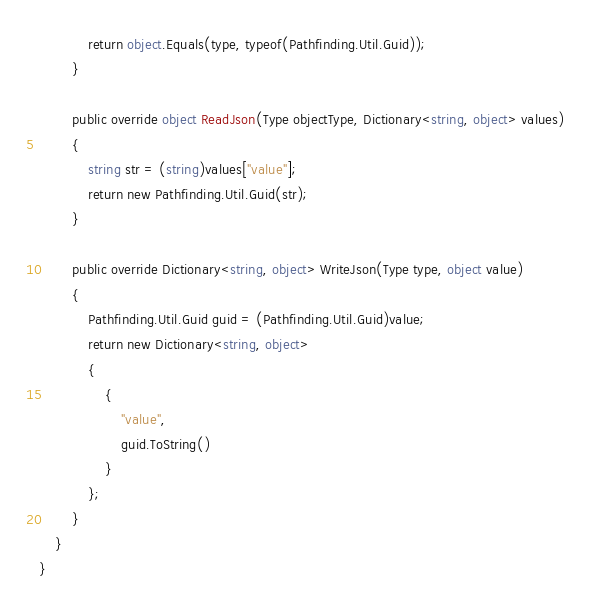Convert code to text. <code><loc_0><loc_0><loc_500><loc_500><_C#_>			return object.Equals(type, typeof(Pathfinding.Util.Guid));
		}

		public override object ReadJson(Type objectType, Dictionary<string, object> values)
		{
			string str = (string)values["value"];
			return new Pathfinding.Util.Guid(str);
		}

		public override Dictionary<string, object> WriteJson(Type type, object value)
		{
			Pathfinding.Util.Guid guid = (Pathfinding.Util.Guid)value;
			return new Dictionary<string, object>
			{
				{
					"value",
					guid.ToString()
				}
			};
		}
	}
}
</code> 